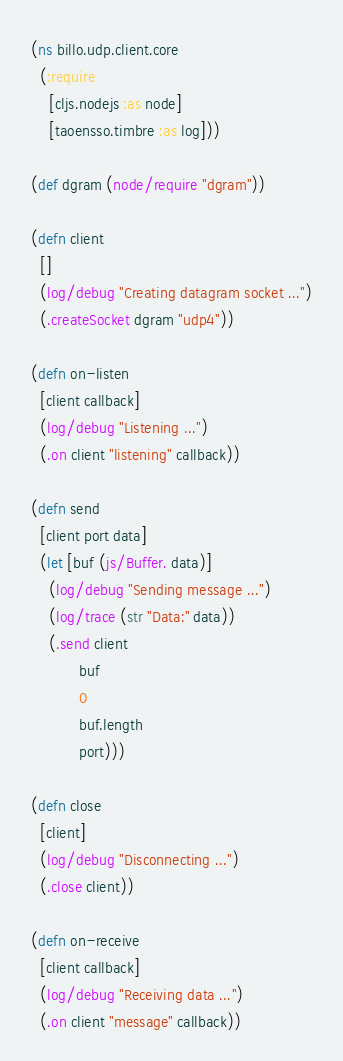<code> <loc_0><loc_0><loc_500><loc_500><_Clojure_>(ns billo.udp.client.core
  (:require
    [cljs.nodejs :as node]
    [taoensso.timbre :as log]))

(def dgram (node/require "dgram"))

(defn client
  []
  (log/debug "Creating datagram socket ...")
  (.createSocket dgram "udp4"))

(defn on-listen
  [client callback]
  (log/debug "Listening ...")
  (.on client "listening" callback))

(defn send
  [client port data]
  (let [buf (js/Buffer. data)]
    (log/debug "Sending message ...")
    (log/trace (str "Data:" data))
    (.send client
           buf
           0
           buf.length
           port)))

(defn close
  [client]
  (log/debug "Disconnecting ...")
  (.close client))

(defn on-receive
  [client callback]
  (log/debug "Receiving data ...")
  (.on client "message" callback))
</code> 